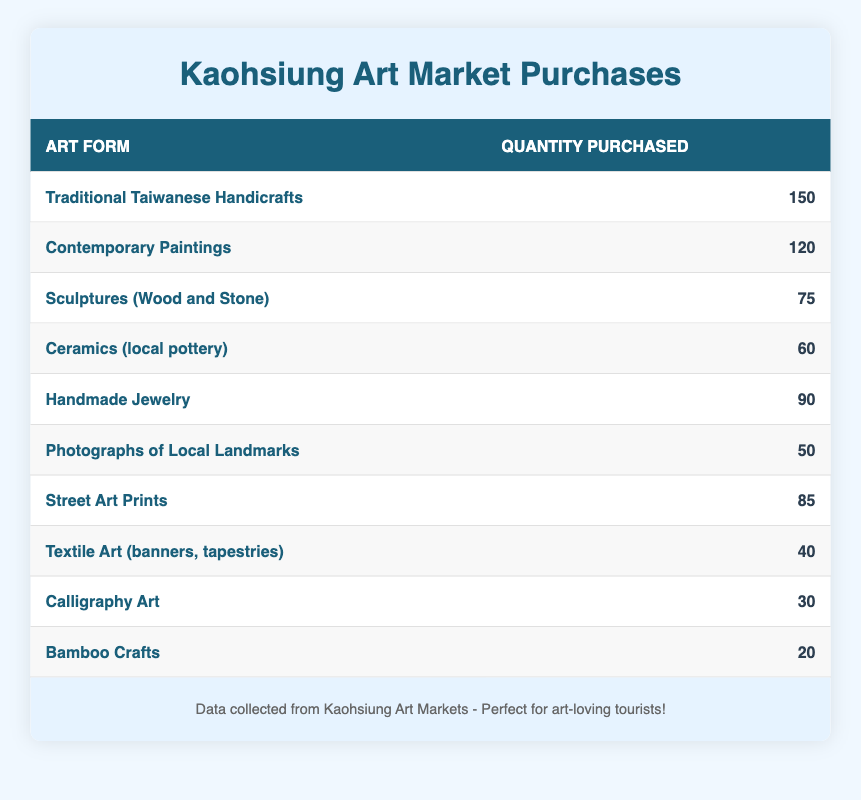What is the quantity of Traditional Taiwanese Handicrafts purchased by visitors? The table lists "Traditional Taiwanese Handicrafts" with a quantity of 150 purchases.
Answer: 150 Which art form had the second-highest quantity purchased? The table shows that "Contemporary Paintings" had the second-highest quantity, with 120 purchases, following "Traditional Taiwanese Handicrafts".
Answer: Contemporary Paintings Is the quantity of photographs of local landmarks greater than that of bamboo crafts? The table shows "Photographs of Local Landmarks" with 50 purchases and "Bamboo Crafts" with 20 purchases. Since 50 is greater than 20, the statement is true.
Answer: Yes What is the total quantity of Handmade Jewelry and Street Art Prints purchased? "Handmade Jewelry" had 90 purchases and "Street Art Prints" had 85 purchases. Adding them gives 90 + 85 = 175.
Answer: 175 Which art form was purchased the least? The table shows "Bamboo Crafts" with the lowest quantity purchased, at 20.
Answer: Bamboo Crafts What is the average quantity purchased for all the art forms listed? The total quantity of all art forms is 150 + 120 + 75 + 60 + 90 + 50 + 85 + 40 + 30 + 20 = 720. There are 10 art forms, so the average is 720 / 10 = 72.
Answer: 72 Are sculptures (wood and stone) purchased more than twice as many as calligraphy art? "Sculptures (Wood and Stone)" had 75 purchases while "Calligraphy Art" had 30 purchases. Twice of 30 is 60, and since 75 is greater than 60, the statement is true.
Answer: Yes What is the difference in quantity purchased between contemporary paintings and ceramics? "Contemporary Paintings" had 120 purchases and "Ceramics (local pottery)" had 60 purchases. The difference is 120 - 60 = 60.
Answer: 60 How many types of art forms had more than 80 items purchased? The table lists "Traditional Taiwanese Handicrafts" (150), "Contemporary Paintings" (120), "Handmade Jewelry" (90), and "Street Art Prints" (85), which totals 4 types of art forms.
Answer: 4 